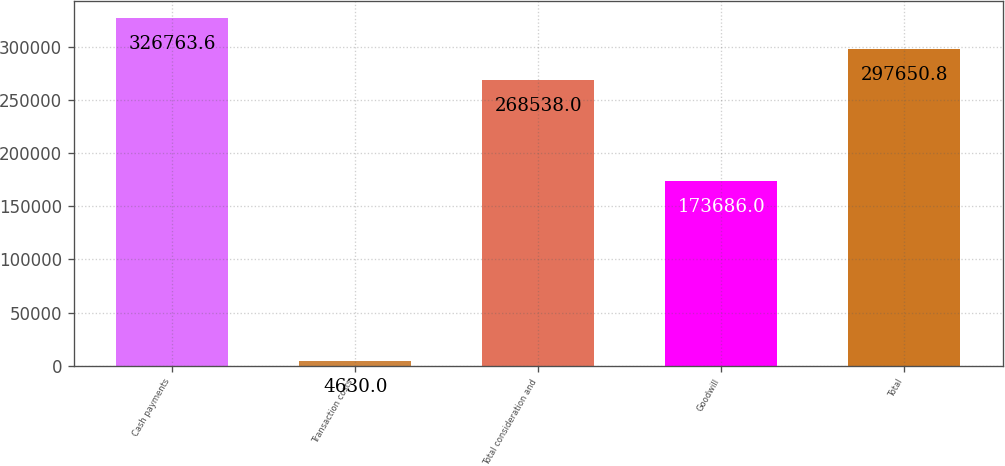<chart> <loc_0><loc_0><loc_500><loc_500><bar_chart><fcel>Cash payments<fcel>Transaction costs<fcel>Total consideration and<fcel>Goodwill<fcel>Total<nl><fcel>326764<fcel>4630<fcel>268538<fcel>173686<fcel>297651<nl></chart> 